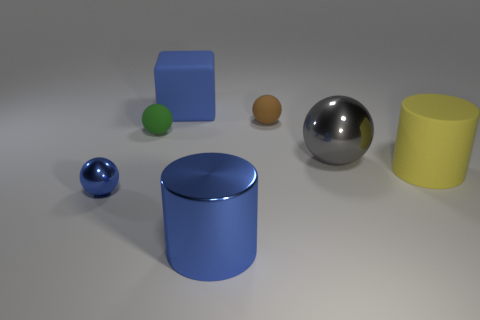There is a brown thing that is the same size as the green matte ball; what is its material?
Your response must be concise. Rubber. What number of small green shiny spheres are there?
Keep it short and to the point. 0. There is a metallic sphere that is behind the tiny blue metallic thing; what is its size?
Ensure brevity in your answer.  Large. Are there the same number of yellow things right of the block and green matte balls?
Your response must be concise. Yes. Are there any big gray objects that have the same shape as the tiny brown object?
Your answer should be compact. Yes. There is a big thing that is both behind the yellow object and on the left side of the gray shiny sphere; what shape is it?
Your answer should be very brief. Cube. Do the large yellow object and the blue object that is behind the big gray metallic object have the same material?
Your response must be concise. Yes. There is a blue rubber block; are there any rubber balls on the right side of it?
Give a very brief answer. Yes. What number of things are brown metal cylinders or objects to the left of the cube?
Make the answer very short. 2. There is a metal sphere on the left side of the metal object behind the tiny blue object; what color is it?
Provide a short and direct response. Blue. 